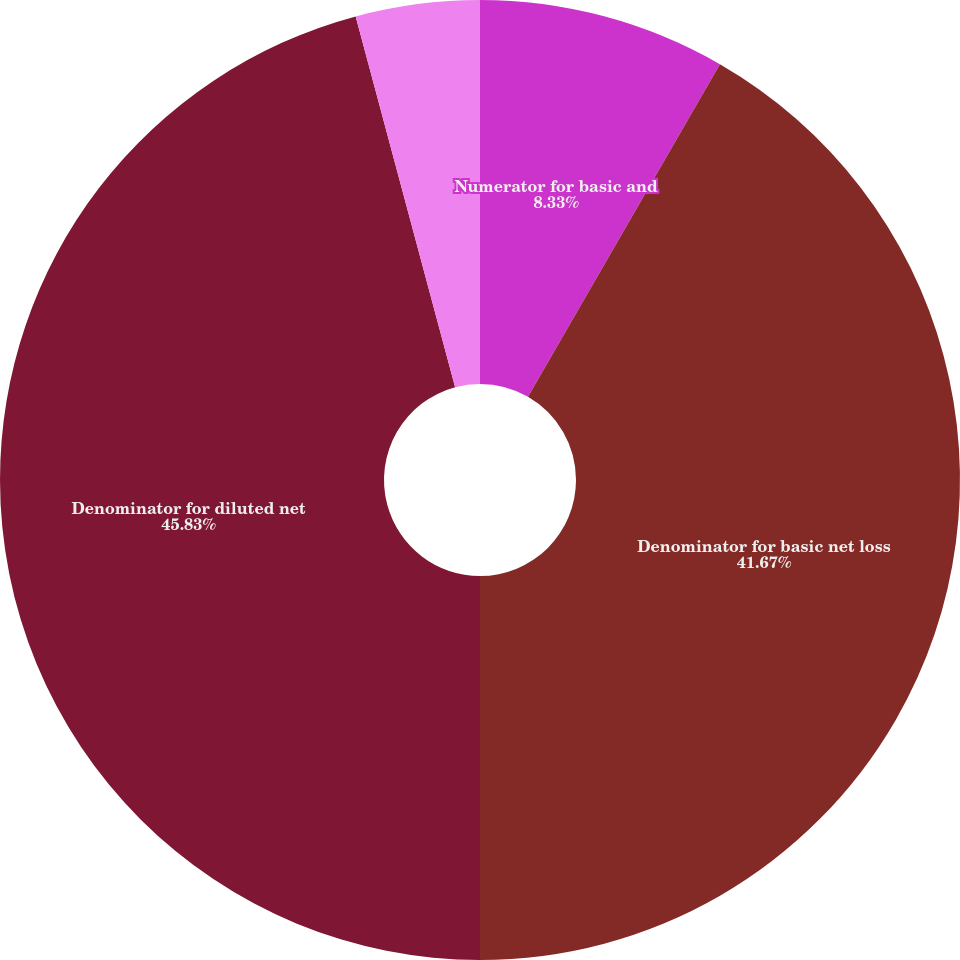<chart> <loc_0><loc_0><loc_500><loc_500><pie_chart><fcel>Numerator for basic and<fcel>Denominator for basic net loss<fcel>Denominator for diluted net<fcel>Basic net loss per share<fcel>Diluted net loss per share<nl><fcel>8.33%<fcel>41.67%<fcel>45.83%<fcel>0.0%<fcel>4.17%<nl></chart> 